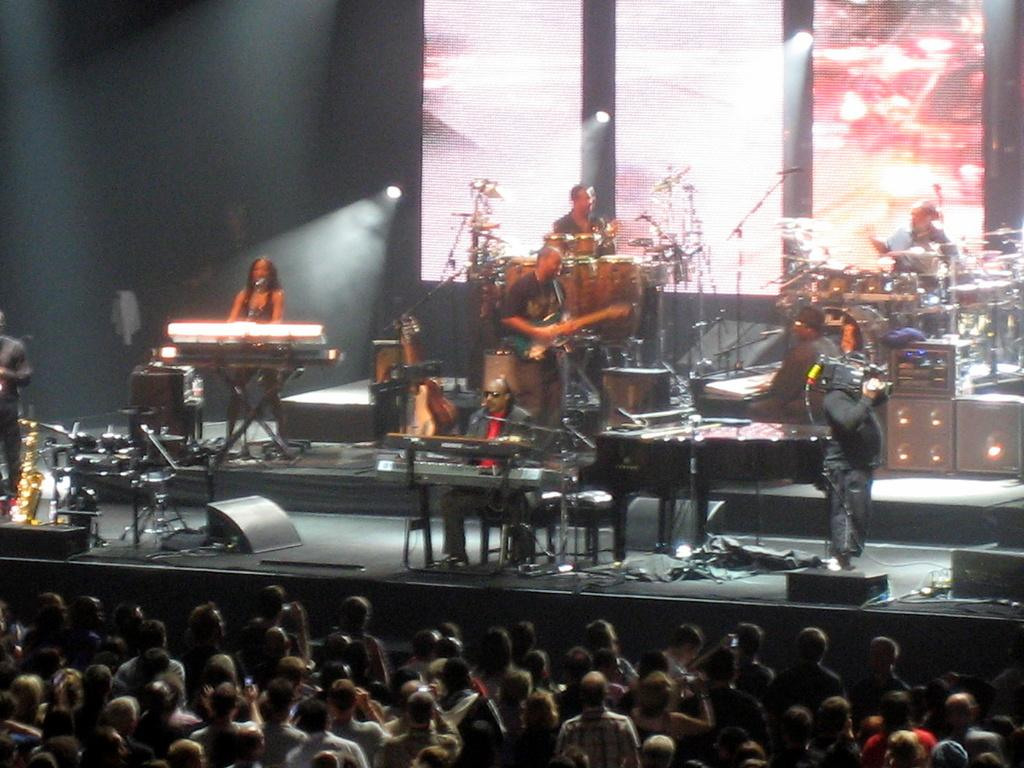What are the people on stage doing? The people on stage are playing musical instruments. What can be seen behind the stage? There is a projector screen behind the stage. Who is watching the performance? There are spectators watching the performance. What type of steam is coming out of the vase on stage? There is no vase or steam present in the image; the people on stage are playing musical instruments. 